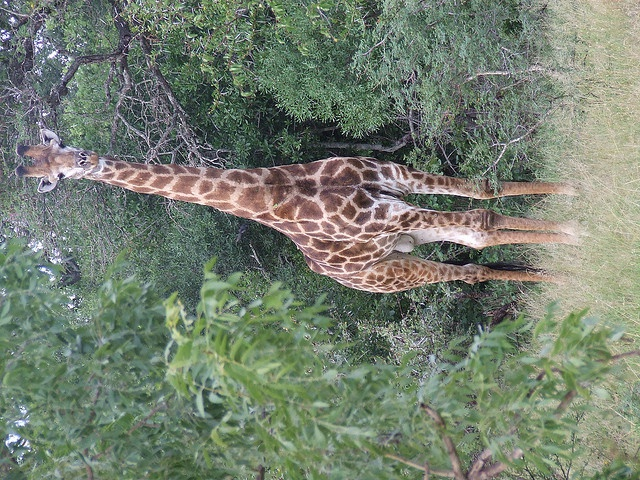Describe the objects in this image and their specific colors. I can see a giraffe in darkgreen, gray, darkgray, and lightgray tones in this image. 